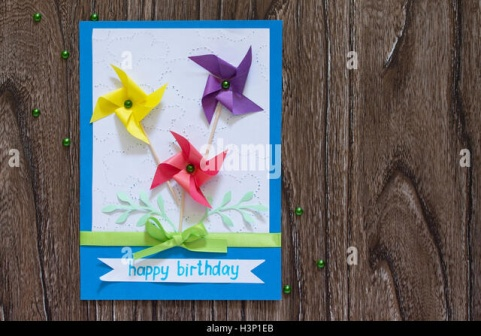Is there a particular reason the colors of the pinwheels were chosen? The colors of the pinwheels—yellow, red, and purple—likely were chosen for their vibrant and eye-catching nature. These colors not only contrast well against the blue and white background of the card but also symbolize different aspects of celebration: yellow for joy and happiness, red for love and excitement, and purple for creativity and imagination. Together, they create a harmonious and festive palette that enhances the overall celebratory mood of the card. How might this birthday card be received by someone celebrating their birthday? Upon receiving this beautifully crafted birthday card, the birthday person would likely feel a wave of happiness and appreciation. The vibrant colors, playful pinwheels, and thoughtful arrangement of elements all convey a sense of joy and celebration. The heartfelt 'happy birthday' message and the careful attention to detail reflect the sender's genuine care and effort, making the recipient feel special and cherished on their big day. This card is sure to bring a smile to their face and set the tone for a joyous birthday celebration. 